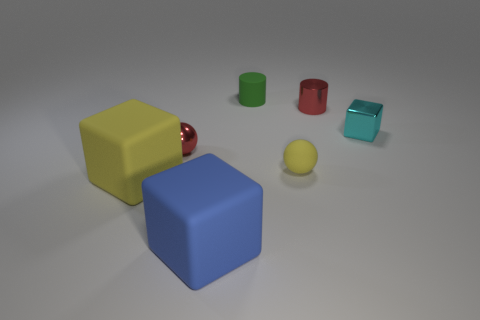Subtract all tiny cyan cubes. How many cubes are left? 2 Add 1 tiny red shiny spheres. How many objects exist? 8 Subtract all green cubes. Subtract all red spheres. How many cubes are left? 3 Subtract all blocks. How many objects are left? 4 Add 6 red things. How many red things are left? 8 Add 4 blue metal balls. How many blue metal balls exist? 4 Subtract 0 red cubes. How many objects are left? 7 Subtract all large yellow things. Subtract all blue rubber things. How many objects are left? 5 